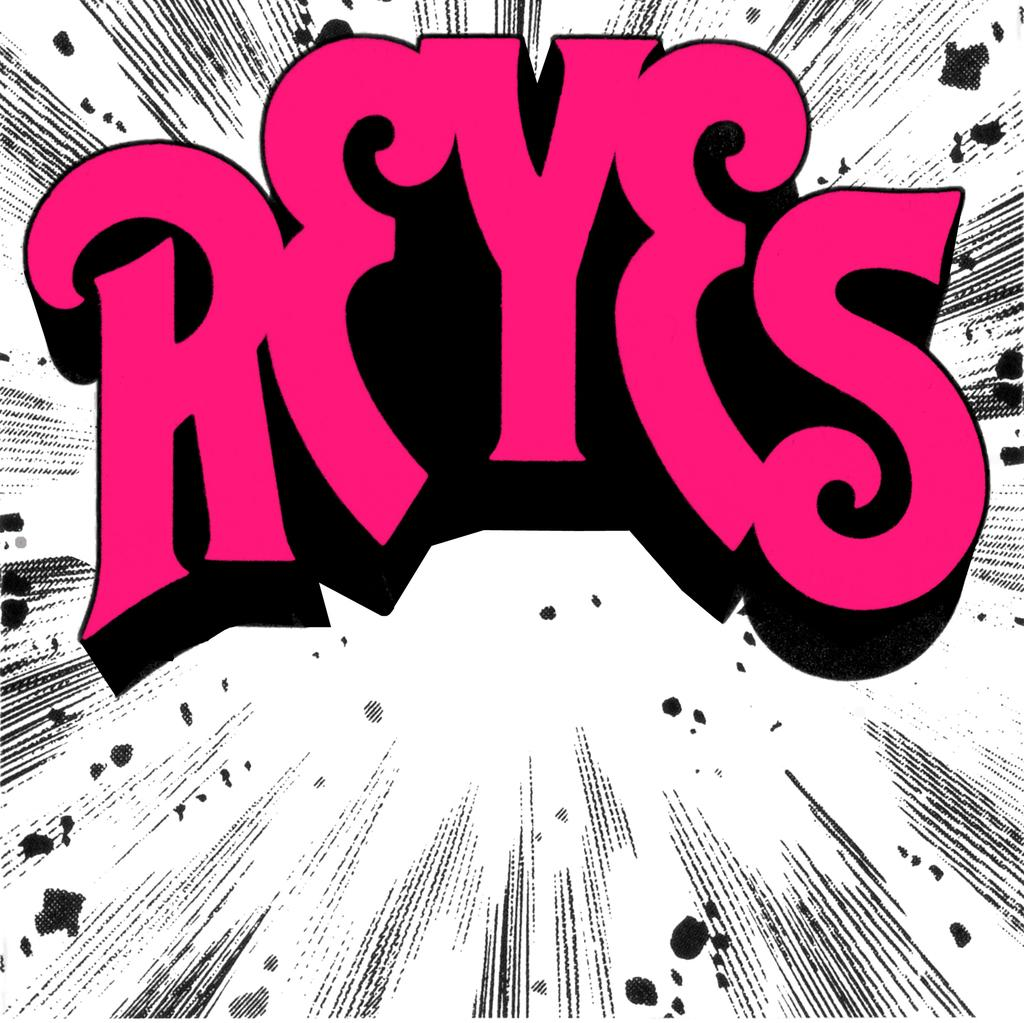<image>
Render a clear and concise summary of the photo. Graphical text in pink that says REYES on a white and black background 